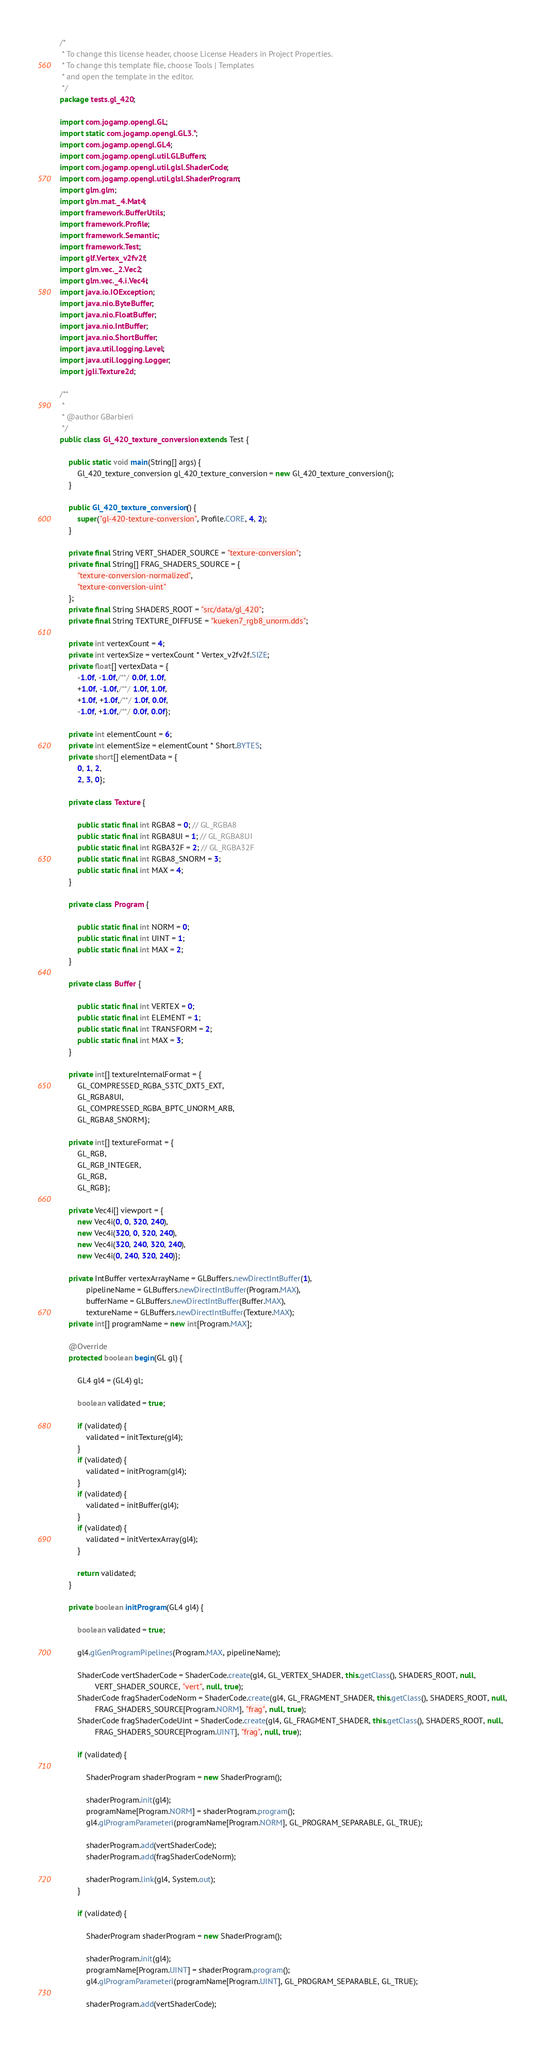<code> <loc_0><loc_0><loc_500><loc_500><_Java_>/*
 * To change this license header, choose License Headers in Project Properties.
 * To change this template file, choose Tools | Templates
 * and open the template in the editor.
 */
package tests.gl_420;

import com.jogamp.opengl.GL;
import static com.jogamp.opengl.GL3.*;
import com.jogamp.opengl.GL4;
import com.jogamp.opengl.util.GLBuffers;
import com.jogamp.opengl.util.glsl.ShaderCode;
import com.jogamp.opengl.util.glsl.ShaderProgram;
import glm.glm;
import glm.mat._4.Mat4;
import framework.BufferUtils;
import framework.Profile;
import framework.Semantic;
import framework.Test;
import glf.Vertex_v2fv2f;
import glm.vec._2.Vec2;
import glm.vec._4.i.Vec4i;
import java.io.IOException;
import java.nio.ByteBuffer;
import java.nio.FloatBuffer;
import java.nio.IntBuffer;
import java.nio.ShortBuffer;
import java.util.logging.Level;
import java.util.logging.Logger;
import jgli.Texture2d;

/**
 *
 * @author GBarbieri
 */
public class Gl_420_texture_conversion extends Test {

    public static void main(String[] args) {
        Gl_420_texture_conversion gl_420_texture_conversion = new Gl_420_texture_conversion();
    }

    public Gl_420_texture_conversion() {
        super("gl-420-texture-conversion", Profile.CORE, 4, 2);
    }

    private final String VERT_SHADER_SOURCE = "texture-conversion";
    private final String[] FRAG_SHADERS_SOURCE = {
        "texture-conversion-normalized",
        "texture-conversion-uint"
    };
    private final String SHADERS_ROOT = "src/data/gl_420";
    private final String TEXTURE_DIFFUSE = "kueken7_rgb8_unorm.dds";

    private int vertexCount = 4;
    private int vertexSize = vertexCount * Vertex_v2fv2f.SIZE;
    private float[] vertexData = {
        -1.0f, -1.0f,/**/ 0.0f, 1.0f,
        +1.0f, -1.0f,/**/ 1.0f, 1.0f,
        +1.0f, +1.0f,/**/ 1.0f, 0.0f,
        -1.0f, +1.0f,/**/ 0.0f, 0.0f};

    private int elementCount = 6;
    private int elementSize = elementCount * Short.BYTES;
    private short[] elementData = {
        0, 1, 2,
        2, 3, 0};

    private class Texture {

        public static final int RGBA8 = 0; // GL_RGBA8
        public static final int RGBA8UI = 1; // GL_RGBA8UI
        public static final int RGBA32F = 2; // GL_RGBA32F
        public static final int RGBA8_SNORM = 3;
        public static final int MAX = 4;
    }

    private class Program {

        public static final int NORM = 0;
        public static final int UINT = 1;
        public static final int MAX = 2;
    }

    private class Buffer {

        public static final int VERTEX = 0;
        public static final int ELEMENT = 1;
        public static final int TRANSFORM = 2;
        public static final int MAX = 3;
    }

    private int[] textureInternalFormat = {
        GL_COMPRESSED_RGBA_S3TC_DXT5_EXT,
        GL_RGBA8UI,
        GL_COMPRESSED_RGBA_BPTC_UNORM_ARB,
        GL_RGBA8_SNORM};

    private int[] textureFormat = {
        GL_RGB,
        GL_RGB_INTEGER,
        GL_RGB,
        GL_RGB};

    private Vec4i[] viewport = {
        new Vec4i(0, 0, 320, 240),
        new Vec4i(320, 0, 320, 240),
        new Vec4i(320, 240, 320, 240),
        new Vec4i(0, 240, 320, 240)};

    private IntBuffer vertexArrayName = GLBuffers.newDirectIntBuffer(1),
            pipelineName = GLBuffers.newDirectIntBuffer(Program.MAX),
            bufferName = GLBuffers.newDirectIntBuffer(Buffer.MAX),
            textureName = GLBuffers.newDirectIntBuffer(Texture.MAX);
    private int[] programName = new int[Program.MAX];

    @Override
    protected boolean begin(GL gl) {

        GL4 gl4 = (GL4) gl;

        boolean validated = true;

        if (validated) {
            validated = initTexture(gl4);
        }
        if (validated) {
            validated = initProgram(gl4);
        }
        if (validated) {
            validated = initBuffer(gl4);
        }
        if (validated) {
            validated = initVertexArray(gl4);
        }

        return validated;
    }

    private boolean initProgram(GL4 gl4) {

        boolean validated = true;

        gl4.glGenProgramPipelines(Program.MAX, pipelineName);

        ShaderCode vertShaderCode = ShaderCode.create(gl4, GL_VERTEX_SHADER, this.getClass(), SHADERS_ROOT, null,
                VERT_SHADER_SOURCE, "vert", null, true);
        ShaderCode fragShaderCodeNorm = ShaderCode.create(gl4, GL_FRAGMENT_SHADER, this.getClass(), SHADERS_ROOT, null,
                FRAG_SHADERS_SOURCE[Program.NORM], "frag", null, true);
        ShaderCode fragShaderCodeUint = ShaderCode.create(gl4, GL_FRAGMENT_SHADER, this.getClass(), SHADERS_ROOT, null,
                FRAG_SHADERS_SOURCE[Program.UINT], "frag", null, true);

        if (validated) {

            ShaderProgram shaderProgram = new ShaderProgram();

            shaderProgram.init(gl4);
            programName[Program.NORM] = shaderProgram.program();
            gl4.glProgramParameteri(programName[Program.NORM], GL_PROGRAM_SEPARABLE, GL_TRUE);

            shaderProgram.add(vertShaderCode);
            shaderProgram.add(fragShaderCodeNorm);

            shaderProgram.link(gl4, System.out);
        }

        if (validated) {

            ShaderProgram shaderProgram = new ShaderProgram();

            shaderProgram.init(gl4);
            programName[Program.UINT] = shaderProgram.program();
            gl4.glProgramParameteri(programName[Program.UINT], GL_PROGRAM_SEPARABLE, GL_TRUE);

            shaderProgram.add(vertShaderCode);</code> 